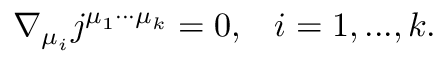<formula> <loc_0><loc_0><loc_500><loc_500>\nabla _ { \mu _ { i } } j ^ { \mu _ { 1 } \cdot \cdot \cdot \mu _ { k } } = 0 , \, i = 1 , \dots , k .</formula> 